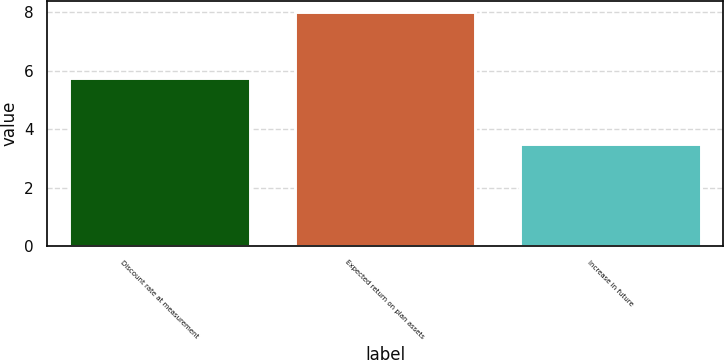Convert chart. <chart><loc_0><loc_0><loc_500><loc_500><bar_chart><fcel>Discount rate at measurement<fcel>Expected return on plan assets<fcel>Increase in future<nl><fcel>5.75<fcel>8<fcel>3.5<nl></chart> 